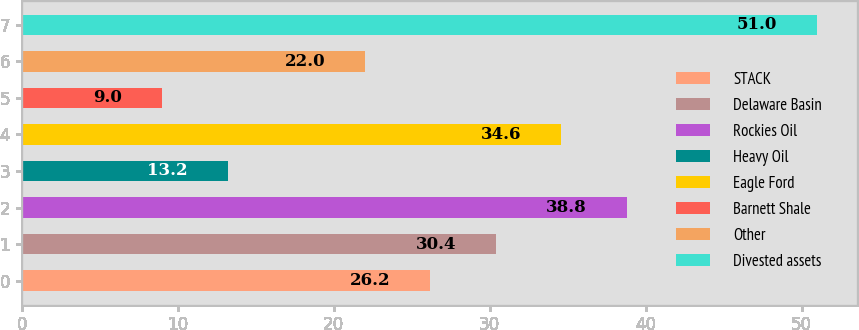<chart> <loc_0><loc_0><loc_500><loc_500><bar_chart><fcel>STACK<fcel>Delaware Basin<fcel>Rockies Oil<fcel>Heavy Oil<fcel>Eagle Ford<fcel>Barnett Shale<fcel>Other<fcel>Divested assets<nl><fcel>26.2<fcel>30.4<fcel>38.8<fcel>13.2<fcel>34.6<fcel>9<fcel>22<fcel>51<nl></chart> 